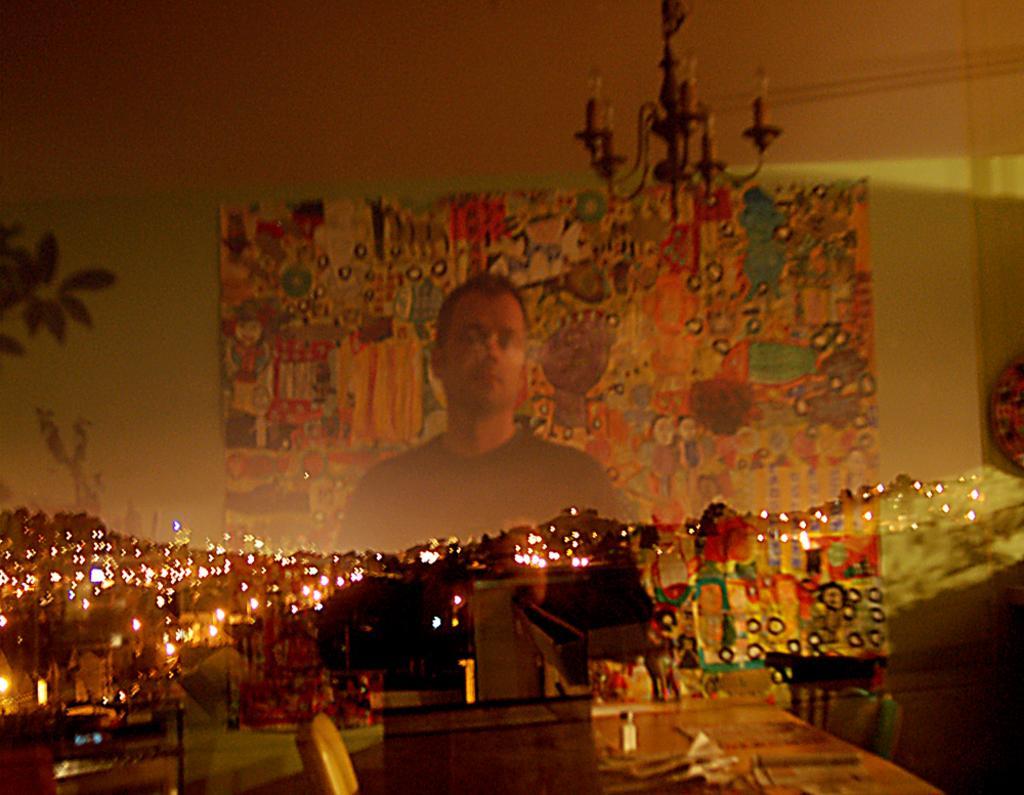Describe this image in one or two sentences. In this image there is a person truncated towards the bottom of the image, there is an object behind the person, there are lights, there is a table truncated towards the bottom of the image, there are objects on the table, there are object truncated towards the bottom of the image, there are object truncated towards the left of the image, there are object truncated towards the right of the image, there is a light truncated towards the top of the image, there is the wall truncated towards the top of the image, there is a plant truncated towards the left of the image. 